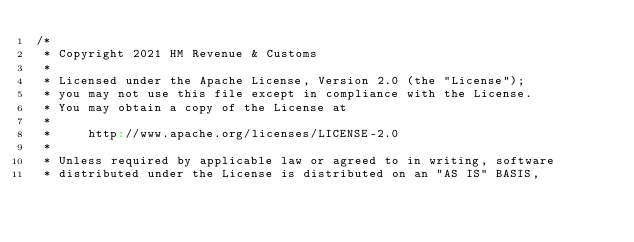<code> <loc_0><loc_0><loc_500><loc_500><_Scala_>/*
 * Copyright 2021 HM Revenue & Customs
 *
 * Licensed under the Apache License, Version 2.0 (the "License");
 * you may not use this file except in compliance with the License.
 * You may obtain a copy of the License at
 *
 *     http://www.apache.org/licenses/LICENSE-2.0
 *
 * Unless required by applicable law or agreed to in writing, software
 * distributed under the License is distributed on an "AS IS" BASIS,</code> 